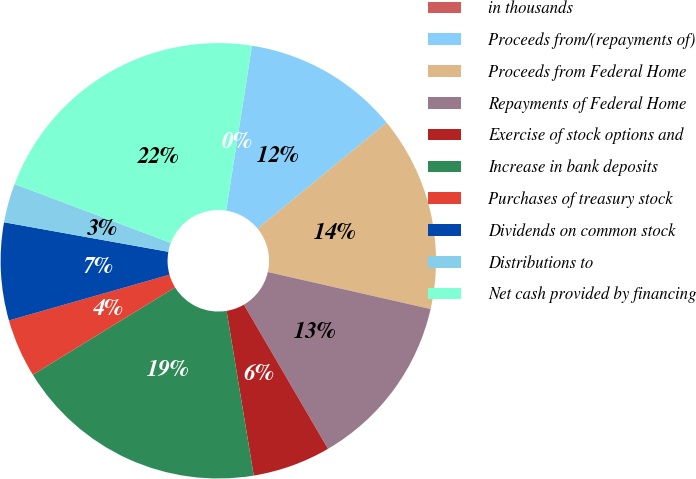<chart> <loc_0><loc_0><loc_500><loc_500><pie_chart><fcel>in thousands<fcel>Proceeds from/(repayments of)<fcel>Proceeds from Federal Home<fcel>Repayments of Federal Home<fcel>Exercise of stock options and<fcel>Increase in bank deposits<fcel>Purchases of treasury stock<fcel>Dividends on common stock<fcel>Distributions to<fcel>Net cash provided by financing<nl><fcel>0.01%<fcel>11.59%<fcel>14.49%<fcel>13.04%<fcel>5.8%<fcel>18.83%<fcel>4.35%<fcel>7.25%<fcel>2.9%<fcel>21.73%<nl></chart> 